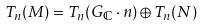<formula> <loc_0><loc_0><loc_500><loc_500>T _ { n } ( M ) = T _ { n } ( G _ { \mathbb { C } } \cdot n ) \oplus T _ { n } ( N )</formula> 